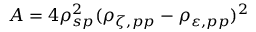<formula> <loc_0><loc_0><loc_500><loc_500>A = 4 \rho _ { s p } ^ { 2 } ( \rho _ { \zeta , p p } - \rho _ { \varepsilon , p p } ) ^ { 2 }</formula> 